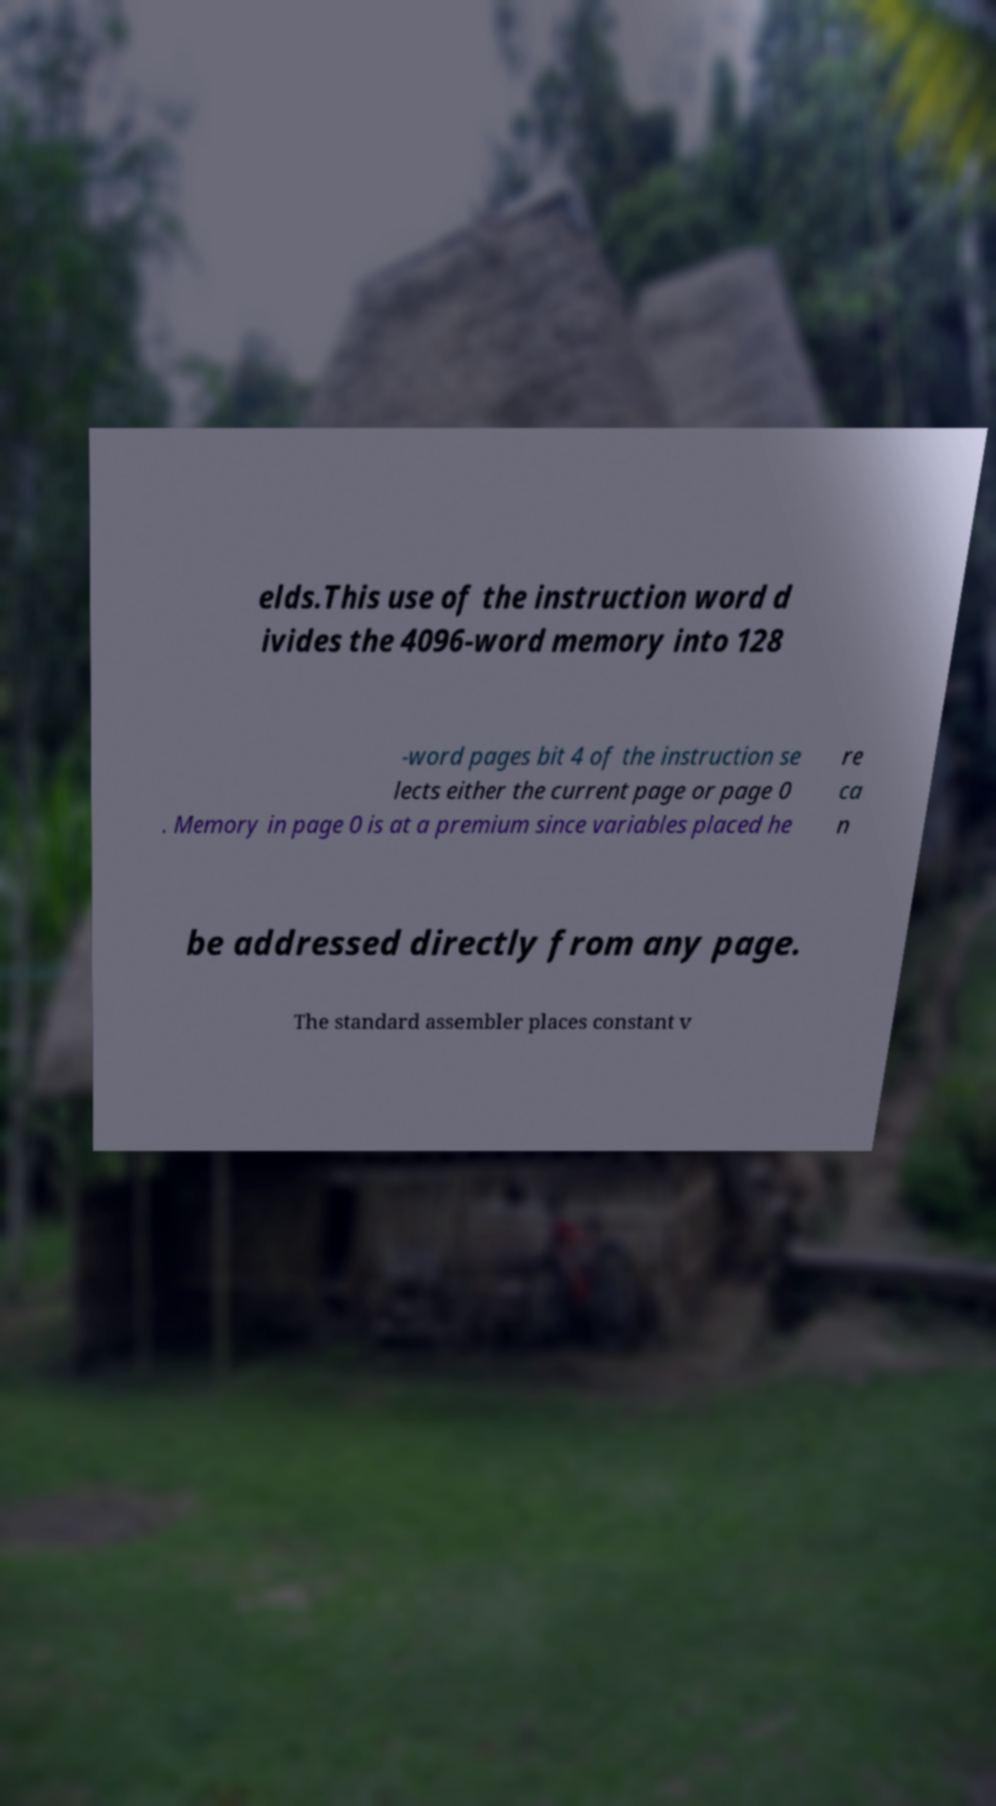Could you extract and type out the text from this image? elds.This use of the instruction word d ivides the 4096-word memory into 128 -word pages bit 4 of the instruction se lects either the current page or page 0 . Memory in page 0 is at a premium since variables placed he re ca n be addressed directly from any page. The standard assembler places constant v 